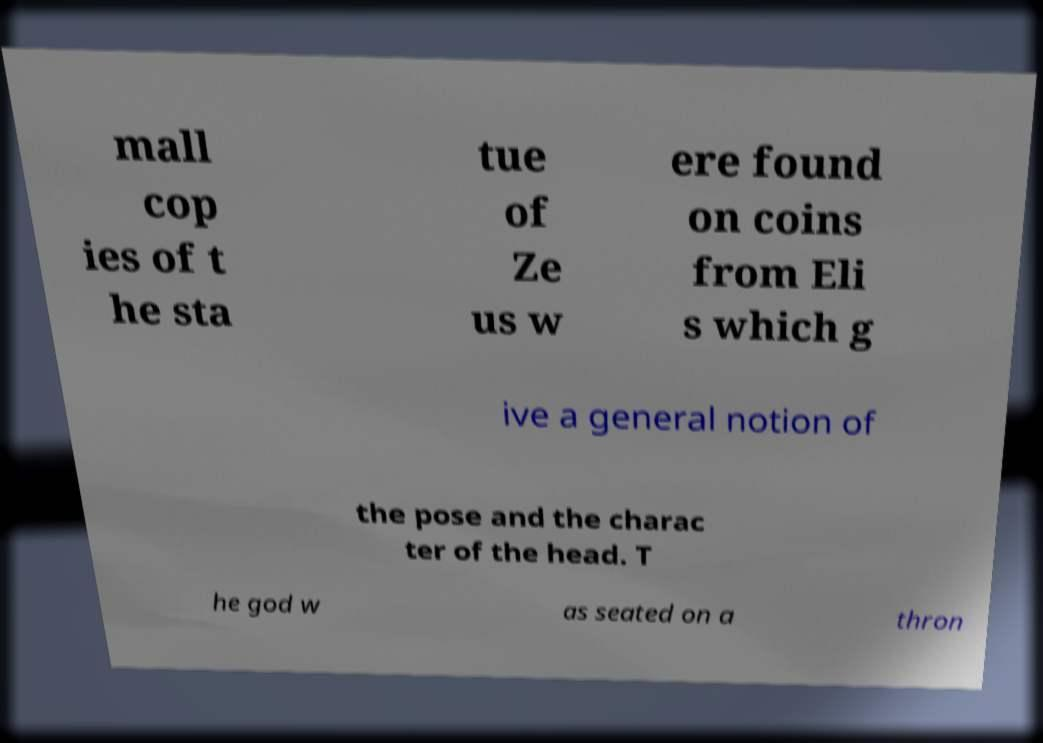There's text embedded in this image that I need extracted. Can you transcribe it verbatim? mall cop ies of t he sta tue of Ze us w ere found on coins from Eli s which g ive a general notion of the pose and the charac ter of the head. T he god w as seated on a thron 